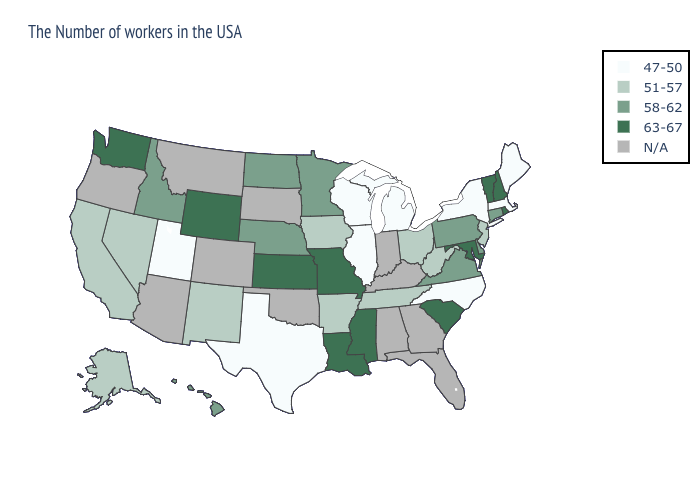What is the value of North Carolina?
Concise answer only. 47-50. Which states have the highest value in the USA?
Keep it brief. Rhode Island, New Hampshire, Vermont, Maryland, South Carolina, Mississippi, Louisiana, Missouri, Kansas, Wyoming, Washington. Name the states that have a value in the range 58-62?
Answer briefly. Connecticut, Delaware, Pennsylvania, Virginia, Minnesota, Nebraska, North Dakota, Idaho, Hawaii. Name the states that have a value in the range 63-67?
Concise answer only. Rhode Island, New Hampshire, Vermont, Maryland, South Carolina, Mississippi, Louisiana, Missouri, Kansas, Wyoming, Washington. Which states have the highest value in the USA?
Quick response, please. Rhode Island, New Hampshire, Vermont, Maryland, South Carolina, Mississippi, Louisiana, Missouri, Kansas, Wyoming, Washington. What is the value of Tennessee?
Short answer required. 51-57. Does the first symbol in the legend represent the smallest category?
Be succinct. Yes. What is the highest value in states that border Idaho?
Keep it brief. 63-67. What is the value of Delaware?
Short answer required. 58-62. What is the highest value in the USA?
Answer briefly. 63-67. What is the value of North Dakota?
Write a very short answer. 58-62. What is the lowest value in states that border Vermont?
Write a very short answer. 47-50. What is the value of Pennsylvania?
Write a very short answer. 58-62. What is the value of New Hampshire?
Write a very short answer. 63-67. 